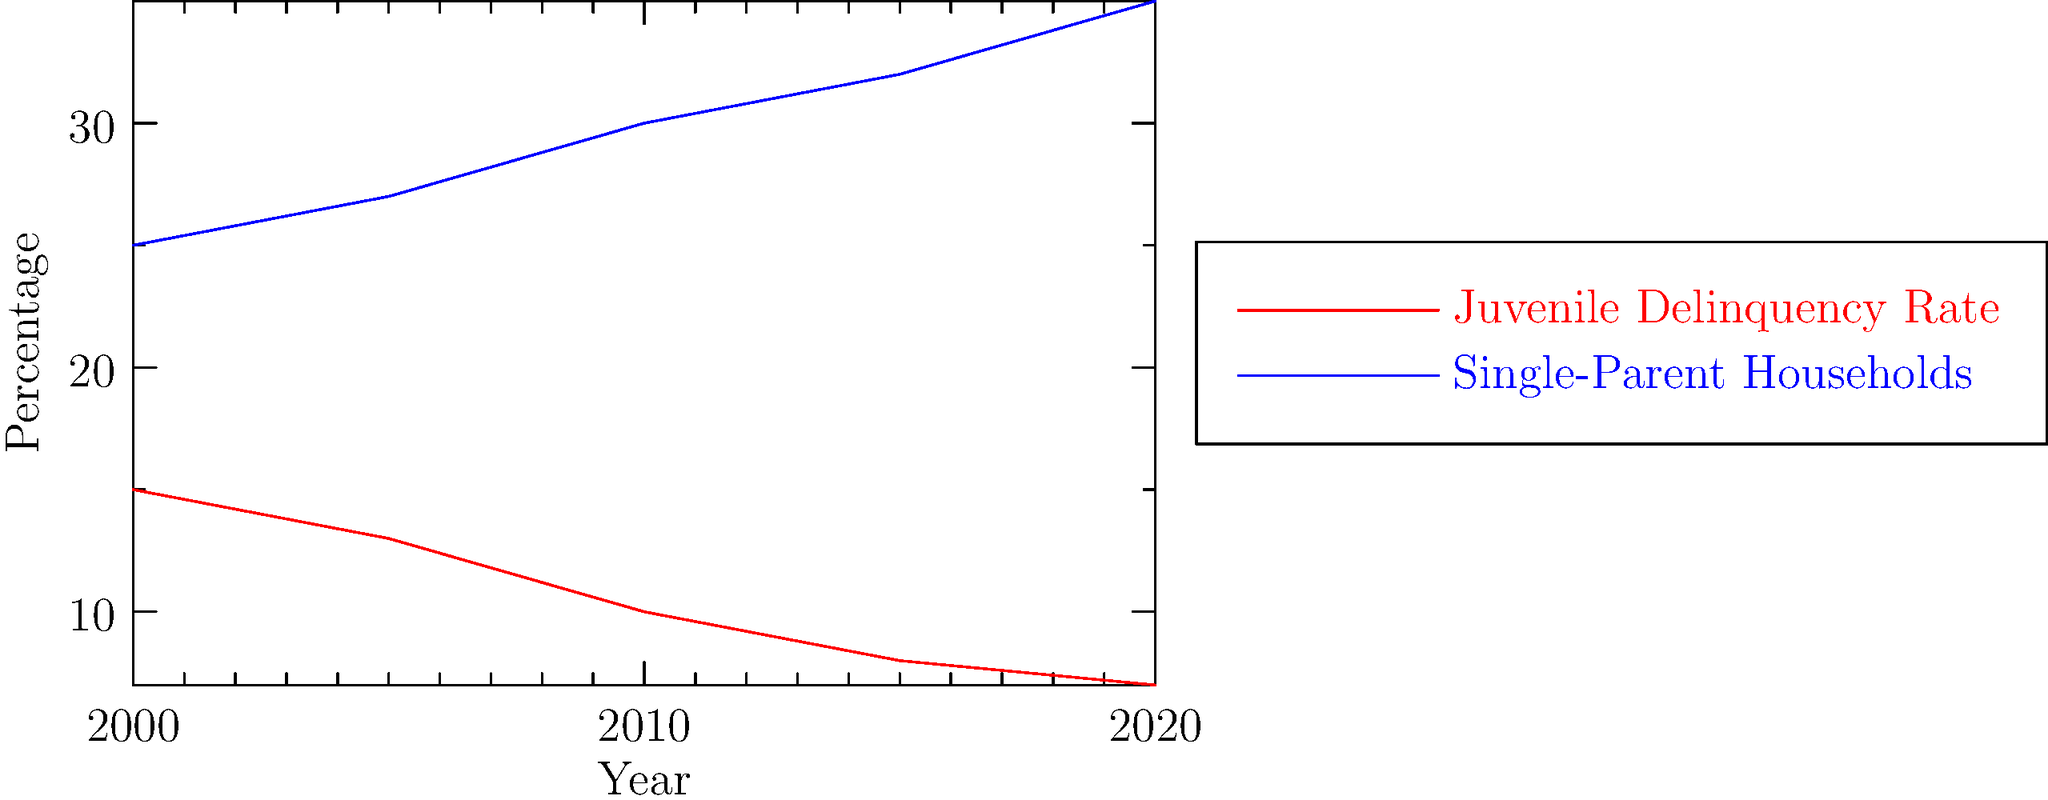Based on the line graph, what is the relationship between the trends in juvenile delinquency rates and the percentage of single-parent households from 2000 to 2020? How might this relate to family dynamics and juvenile delinquency? To answer this question, we need to analyze the trends in both lines on the graph:

1. Juvenile Delinquency Rate (red line):
   - Shows a steady decrease from 2000 to 2020
   - Starts at about 15% in 2000 and drops to around 7% by 2020

2. Single-Parent Households (blue line):
   - Shows a consistent increase from 2000 to 2020
   - Begins at approximately 25% in 2000 and rises to about 35% by 2020

3. Relationship between the two trends:
   - As the percentage of single-parent households increases, the juvenile delinquency rate decreases
   - This relationship appears to be inverse or negative

4. Interpretation related to family dynamics and juvenile delinquency:
   - The data challenges the common assumption that single-parent households lead to higher rates of juvenile delinquency
   - Other factors may be influencing the decrease in juvenile delinquency rates, such as:
     a) Improved support systems for single-parent families
     b) Better community resources and programs for at-risk youth
     c) Changes in societal attitudes and policies regarding juvenile offenders

5. Implications for research:
   - The relationship between family structure and juvenile delinquency may be more complex than previously thought
   - Further investigation is needed to understand the factors contributing to the decrease in juvenile delinquency despite the increase in single-parent households
Answer: Inverse relationship; challenges assumptions about single-parent households and juvenile delinquency. 